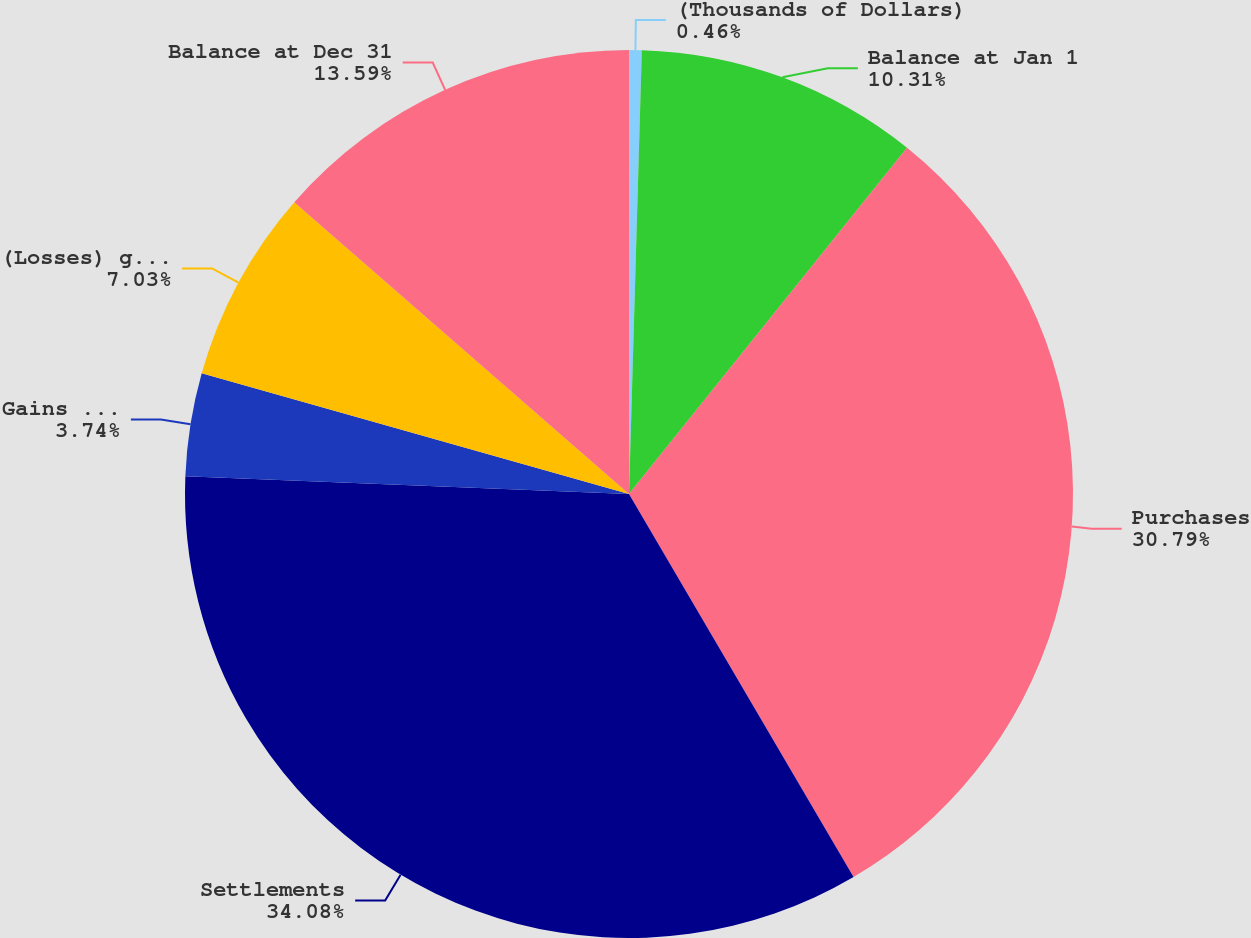Convert chart. <chart><loc_0><loc_0><loc_500><loc_500><pie_chart><fcel>(Thousands of Dollars)<fcel>Balance at Jan 1<fcel>Purchases<fcel>Settlements<fcel>Gains recognized in earnings<fcel>(Losses) gains recognized as<fcel>Balance at Dec 31<nl><fcel>0.46%<fcel>10.31%<fcel>30.79%<fcel>34.08%<fcel>3.74%<fcel>7.03%<fcel>13.59%<nl></chart> 